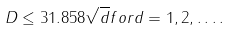<formula> <loc_0><loc_0><loc_500><loc_500>D \leq 3 1 . 8 5 8 \sqrt { d } f o r d = 1 , 2 , \dots .</formula> 